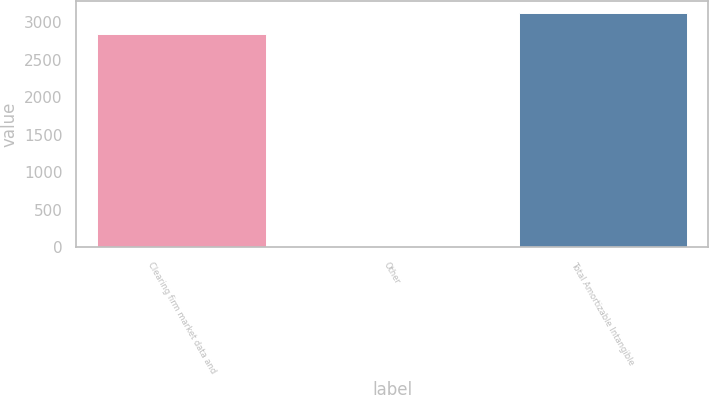<chart> <loc_0><loc_0><loc_500><loc_500><bar_chart><fcel>Clearing firm market data and<fcel>Other<fcel>Total Amortizable Intangible<nl><fcel>2838.8<fcel>2.4<fcel>3125.62<nl></chart> 